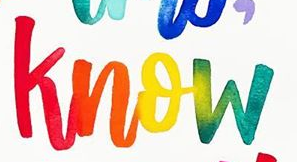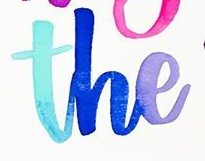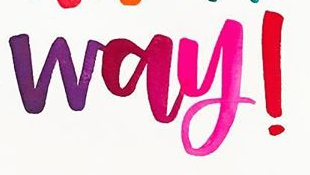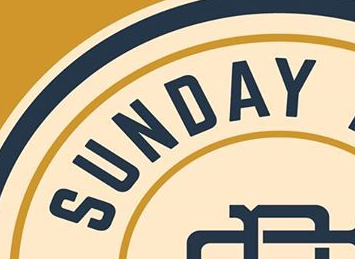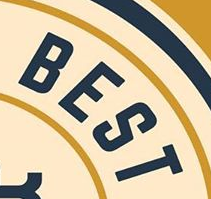Identify the words shown in these images in order, separated by a semicolon. know; the; way!; SUNDAY; BEST 